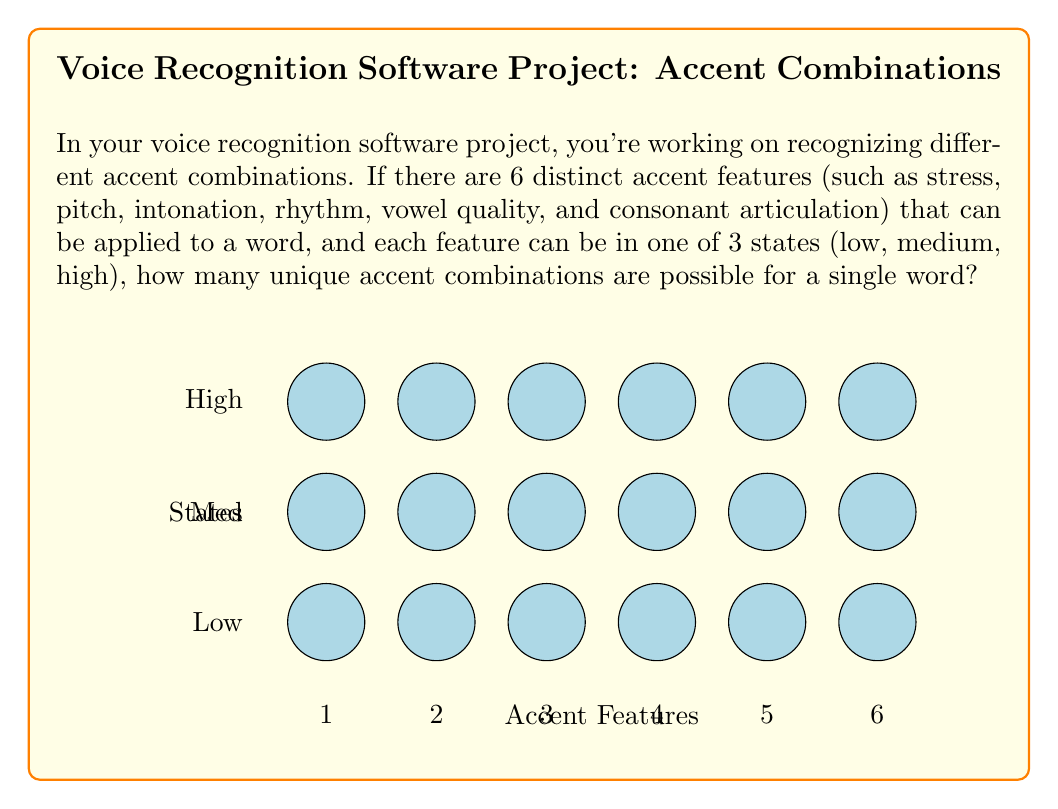Show me your answer to this math problem. Let's approach this step-by-step:

1) We are dealing with a permutation problem where the order matters (different combinations of accent features create different overall accents).

2) For each accent feature, we have 3 choices (low, medium, high).

3) We need to make this choice for all 6 accent features.

4) This scenario follows the multiplication principle of counting.

5) The total number of possible combinations is:

   $$3 \times 3 \times 3 \times 3 \times 3 \times 3 = 3^6$$

6) We can calculate this:

   $$3^6 = 3 \times 3 \times 3 \times 3 \times 3 \times 3 = 729$$

Therefore, there are 729 possible unique accent combinations for a single word with these parameters.
Answer: $3^6 = 729$ 